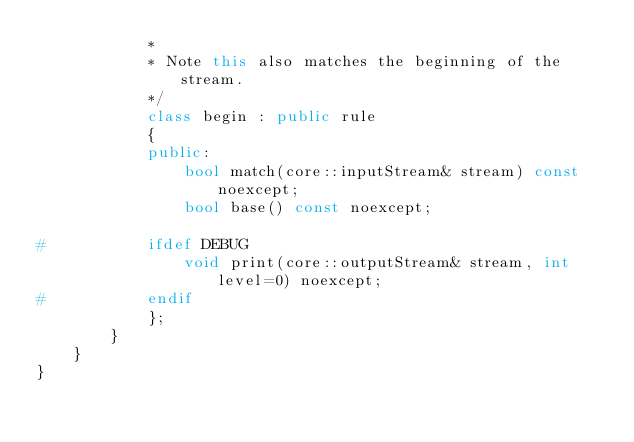<code> <loc_0><loc_0><loc_500><loc_500><_C++_>			*
			* Note this also matches the beginning of the stream.
			*/
			class begin : public rule
			{
			public:
				bool match(core::inputStream& stream) const noexcept;
				bool base() const noexcept;

#			ifdef DEBUG
				void print(core::outputStream& stream, int level=0) noexcept;
#			endif
			};
		}
	}
}
</code> 